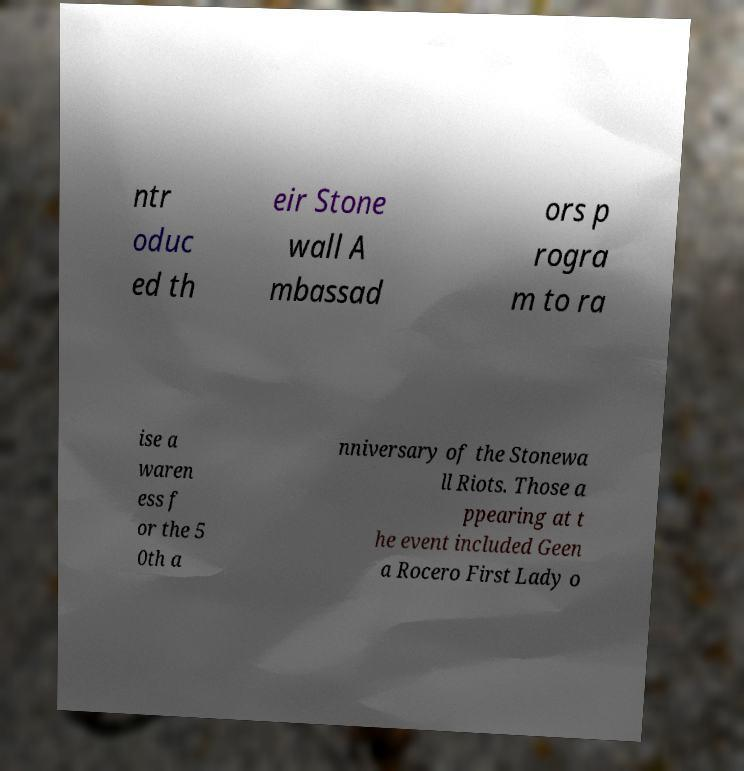There's text embedded in this image that I need extracted. Can you transcribe it verbatim? ntr oduc ed th eir Stone wall A mbassad ors p rogra m to ra ise a waren ess f or the 5 0th a nniversary of the Stonewa ll Riots. Those a ppearing at t he event included Geen a Rocero First Lady o 